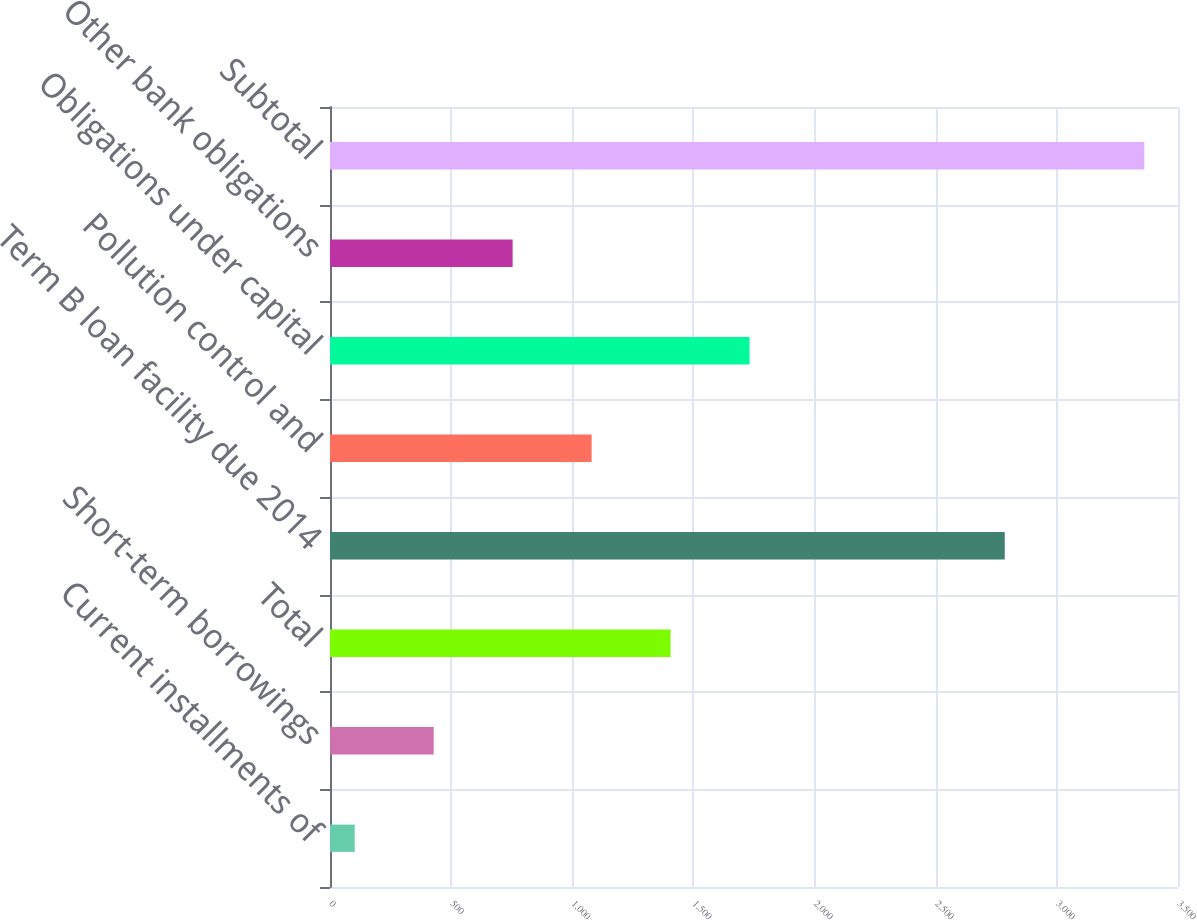Convert chart to OTSL. <chart><loc_0><loc_0><loc_500><loc_500><bar_chart><fcel>Current installments of<fcel>Short-term borrowings<fcel>Total<fcel>Term B loan facility due 2014<fcel>Pollution control and<fcel>Obligations under capital<fcel>Other bank obligations<fcel>Subtotal<nl><fcel>102<fcel>427.9<fcel>1405.6<fcel>2785<fcel>1079.7<fcel>1731.5<fcel>753.8<fcel>3361<nl></chart> 